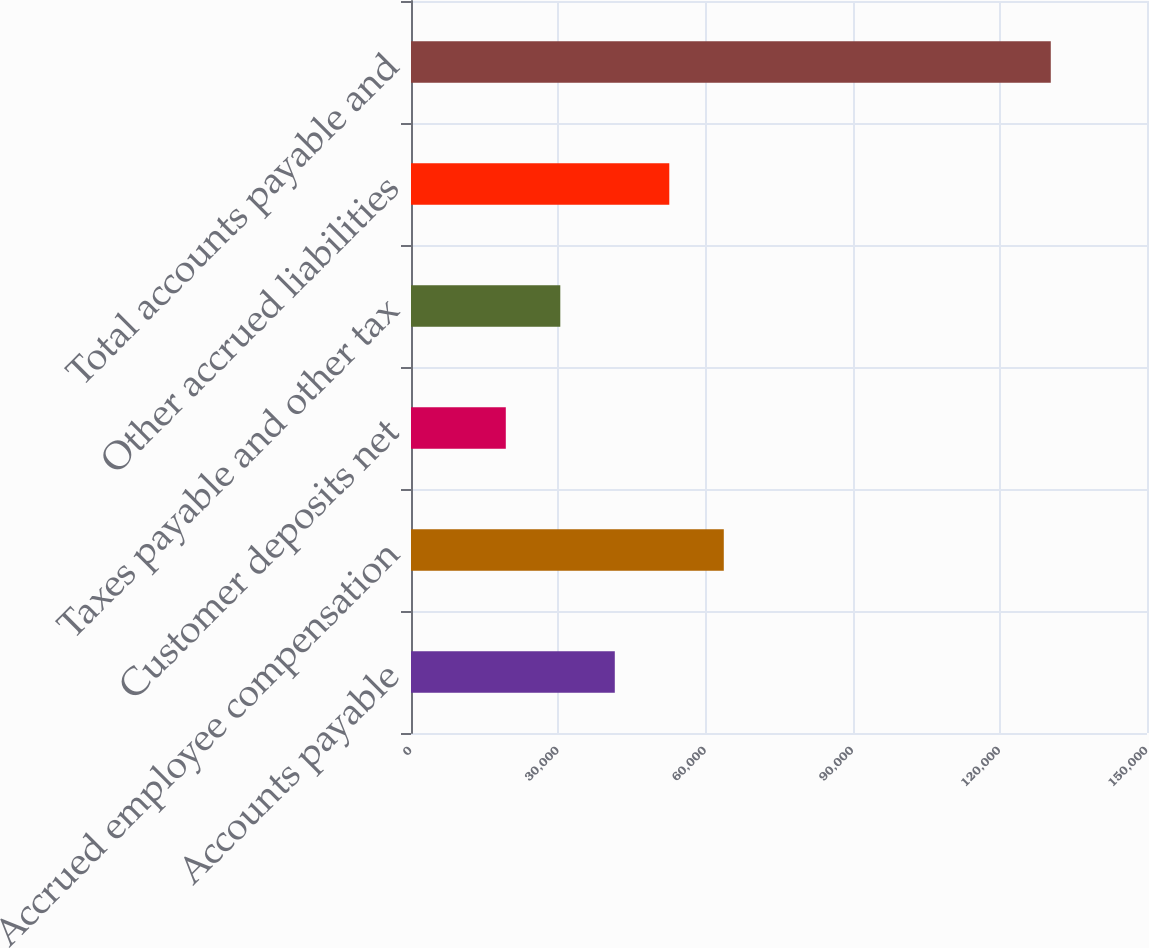<chart> <loc_0><loc_0><loc_500><loc_500><bar_chart><fcel>Accounts payable<fcel>Accrued employee compensation<fcel>Customer deposits net<fcel>Taxes payable and other tax<fcel>Other accrued liabilities<fcel>Total accounts payable and<nl><fcel>41535<fcel>63749<fcel>19321<fcel>30428<fcel>52642<fcel>130391<nl></chart> 